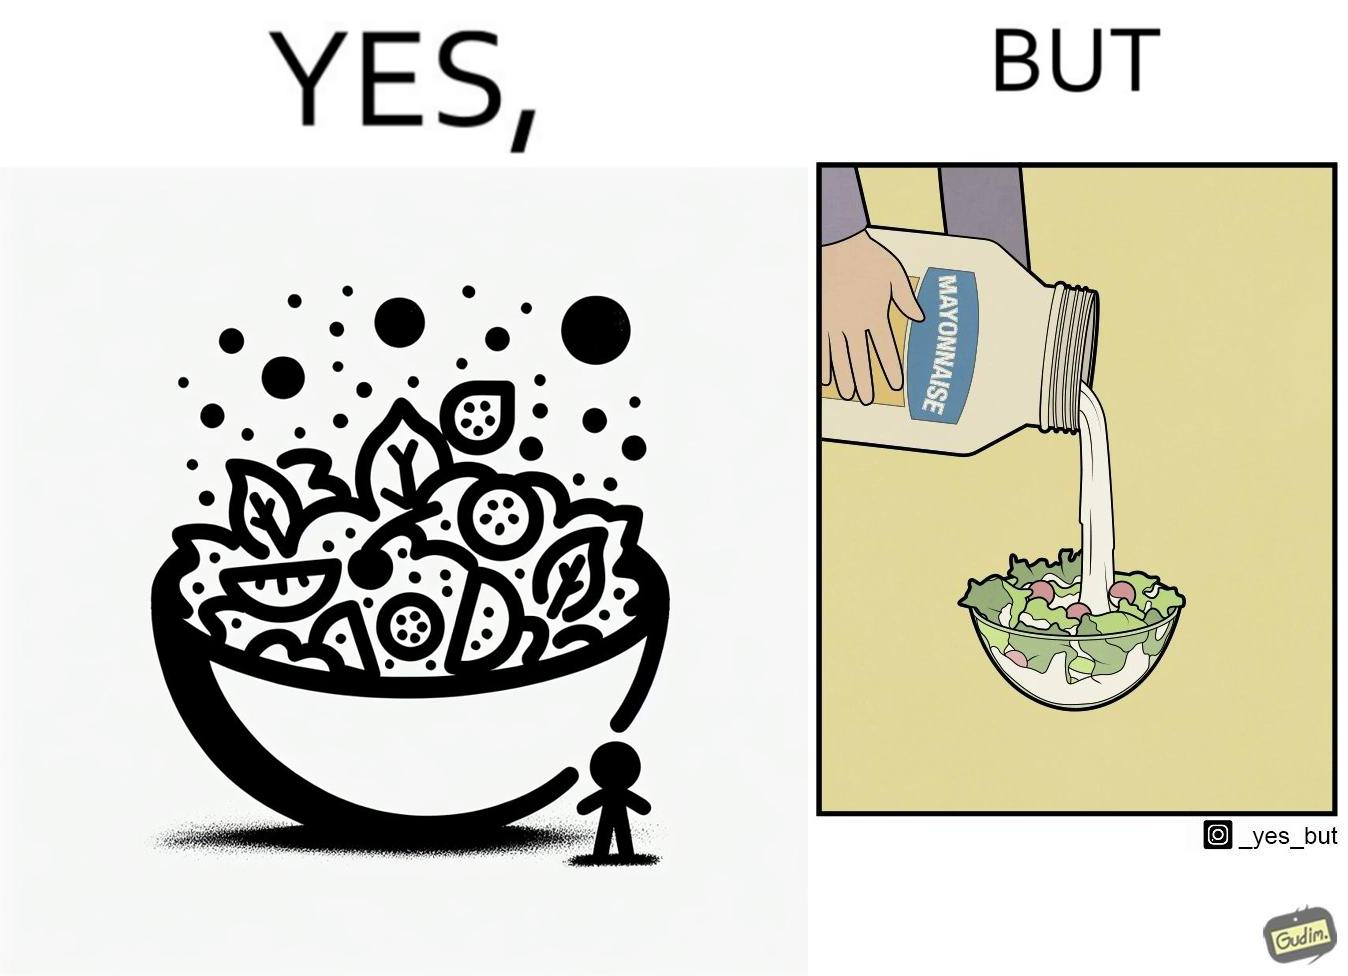What is the satirical meaning behind this image? The image is ironical, as salad in a bowl by itself is very healthy. However, when people have it with Mayonnaise sauce to improve the taste, it is not healthy anymore, and defeats the point of having nutrient-rich salad altogether. 